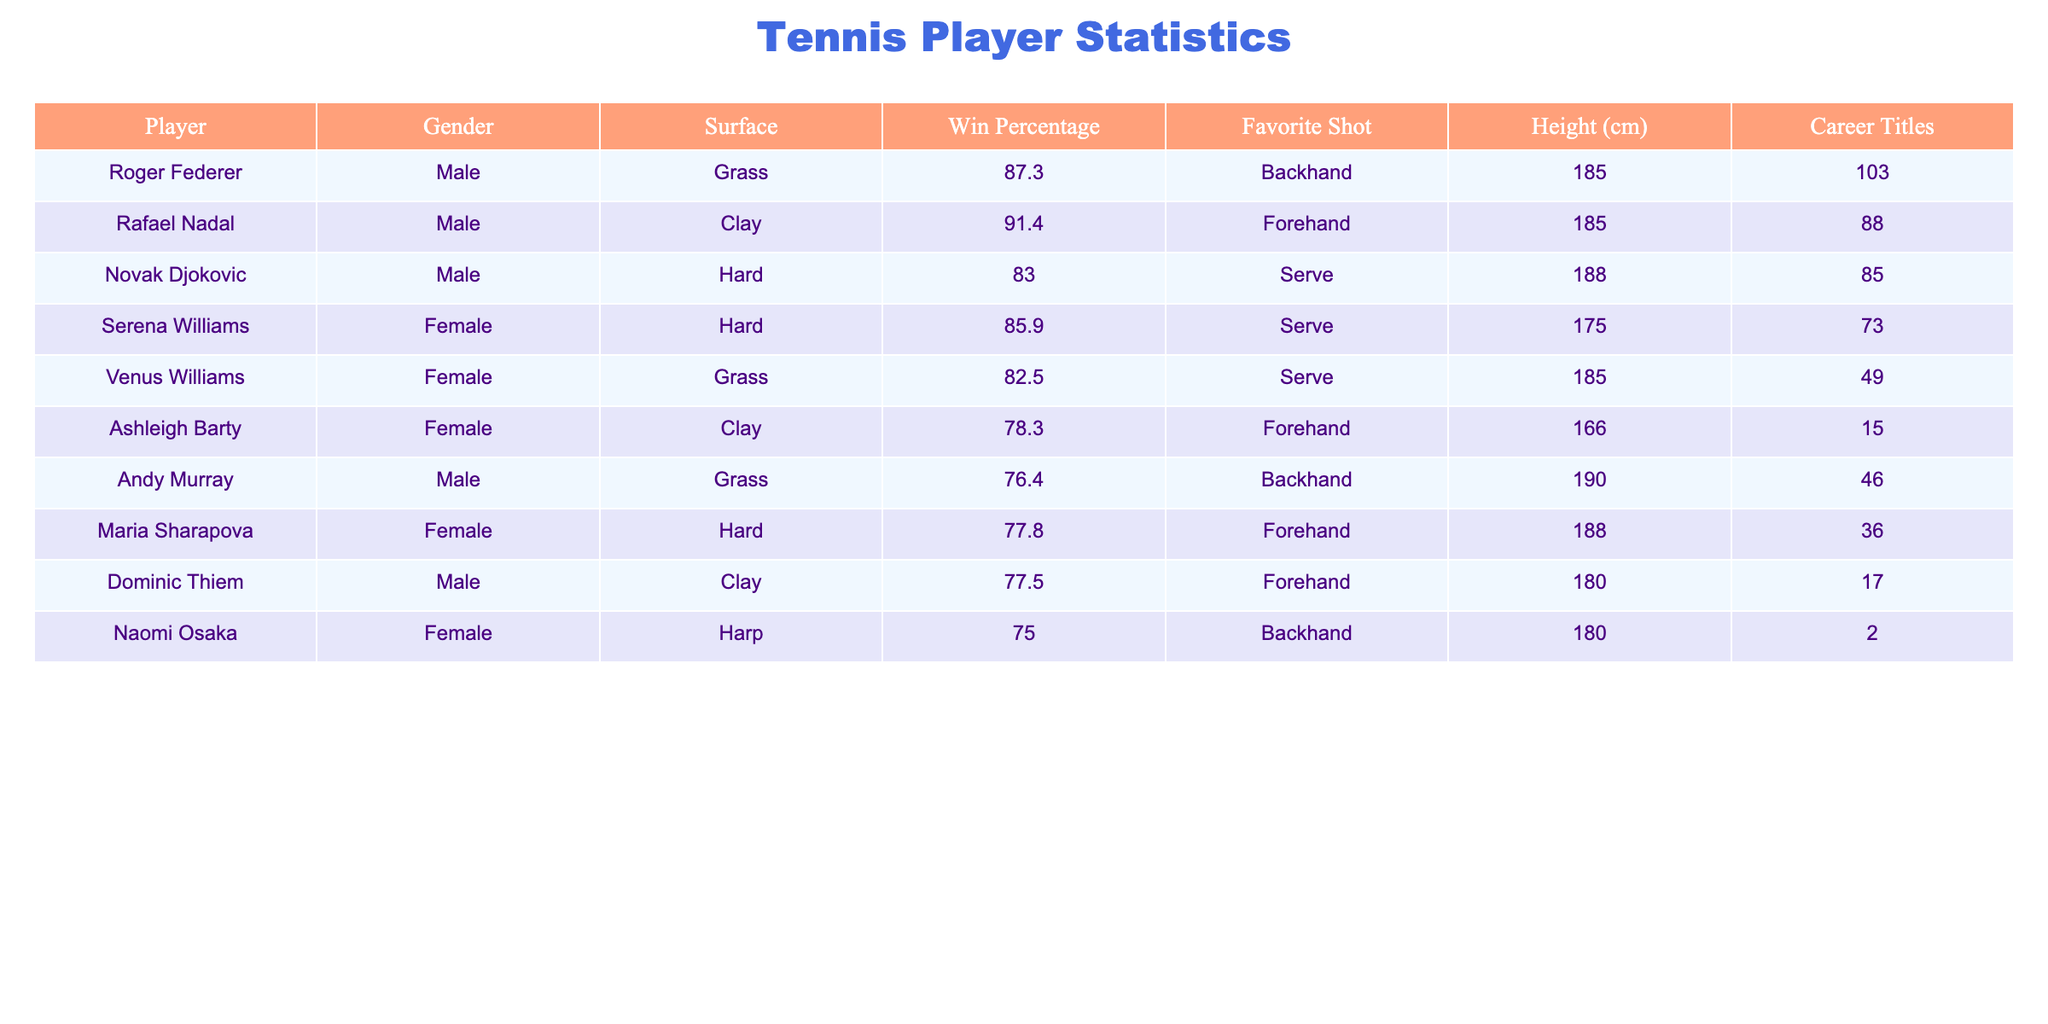What is the win percentage of Rafael Nadal? The table indicates that Rafael Nadal has a win percentage of 91.4% listed under the respective column.
Answer: 91.4% Which player has the tallest height? By comparing the height values of all players listed, Novak Djokovic has the tallest height at 188 cm.
Answer: 188 cm Is Naomi Osaka's favorite shot a backhand? According to the table, Naomi Osaka's favorite shot is indeed listed as a backhand.
Answer: Yes What is the average career titles for male players? The career titles of male players are: 103 (Federer), 88 (Nadal), 85 (Djokovic), 76 (Murray), and 17 (Thiem). Summing these gives 409 titles. There are 5 players, so the average is 409/5 = 81.8.
Answer: 81.8 Which female player has the highest win percentage? The win percentages for female players are 85.9% (Serena Williams), 82.5% (Venus Williams), 78.3% (Ashleigh Barty), and 77.8% (Maria Sharapova). The highest among them is 85.9% from Serena Williams.
Answer: 85.9% How many total titles do all players combined have? Adding the career titles from the table gives us: 103 (Federer) + 88 (Nadal) + 85 (Djokovic) + 73 (Serena) + 49 (Venus) + 15 (Barty) + 46 (Murray) + 36 (Sharapova) + 17 (Thiem) + 2 (Osaka) = 494 total titles.
Answer: 494 Is Ashleigh Barty's preferred surface grass? The table shows Ashleigh Barty's preferred surface is clay, not grass.
Answer: No What is the win percentage difference between Roger Federer and Andy Murray? Roger Federer has a win percentage of 87.3% and Andy Murray has 76.4%. The difference is 87.3 - 76.4 = 10.9%.
Answer: 10.9% 